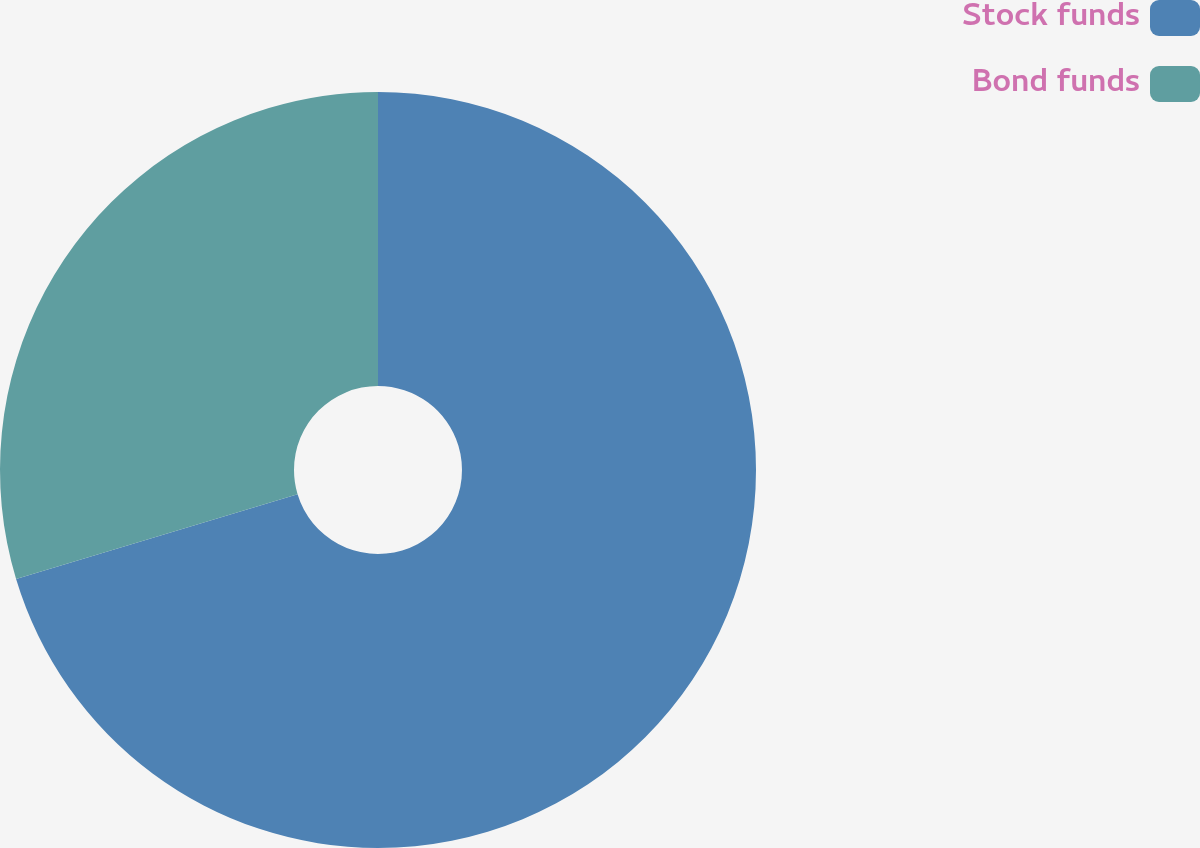Convert chart. <chart><loc_0><loc_0><loc_500><loc_500><pie_chart><fcel>Stock funds<fcel>Bond funds<nl><fcel>70.34%<fcel>29.66%<nl></chart> 